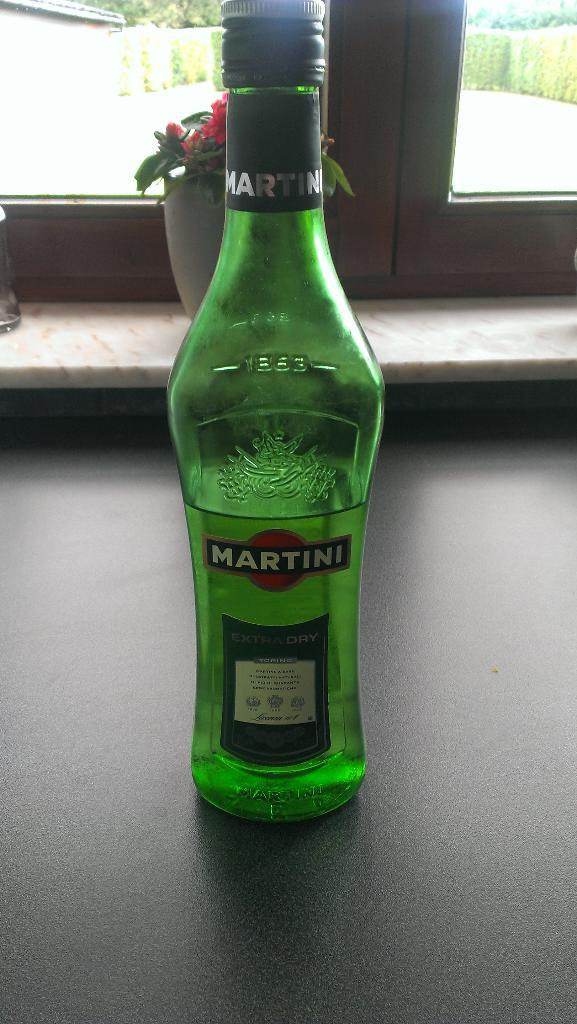Provide a one-sentence caption for the provided image. A green Martini bottle of extra dry liquor on a counter by a window. 